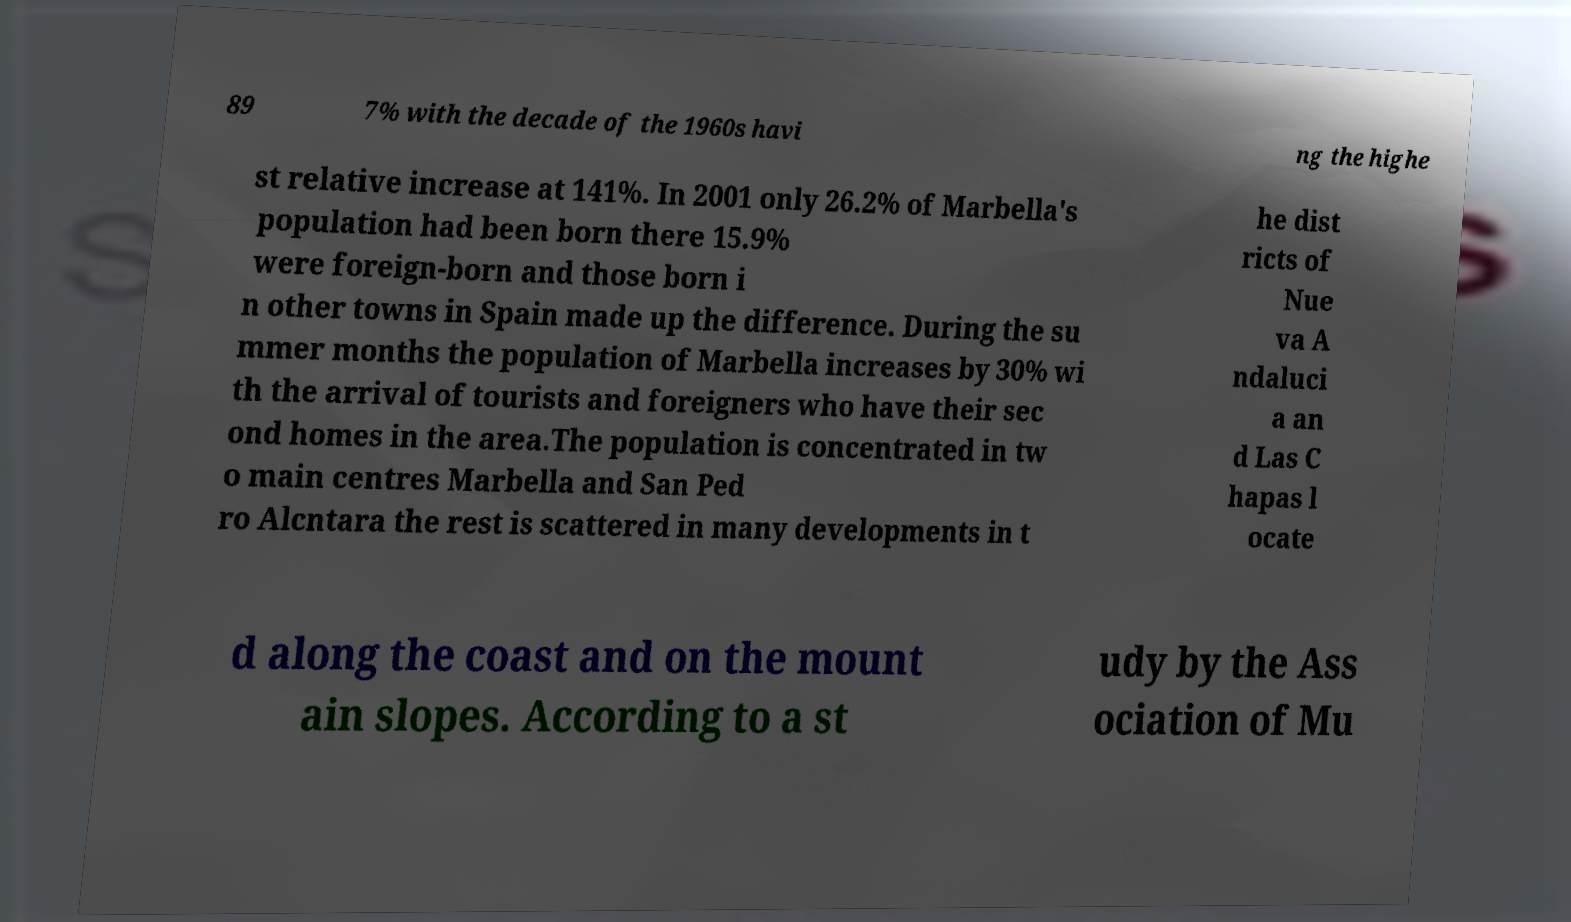I need the written content from this picture converted into text. Can you do that? 89 7% with the decade of the 1960s havi ng the highe st relative increase at 141%. In 2001 only 26.2% of Marbella's population had been born there 15.9% were foreign-born and those born i n other towns in Spain made up the difference. During the su mmer months the population of Marbella increases by 30% wi th the arrival of tourists and foreigners who have their sec ond homes in the area.The population is concentrated in tw o main centres Marbella and San Ped ro Alcntara the rest is scattered in many developments in t he dist ricts of Nue va A ndaluci a an d Las C hapas l ocate d along the coast and on the mount ain slopes. According to a st udy by the Ass ociation of Mu 